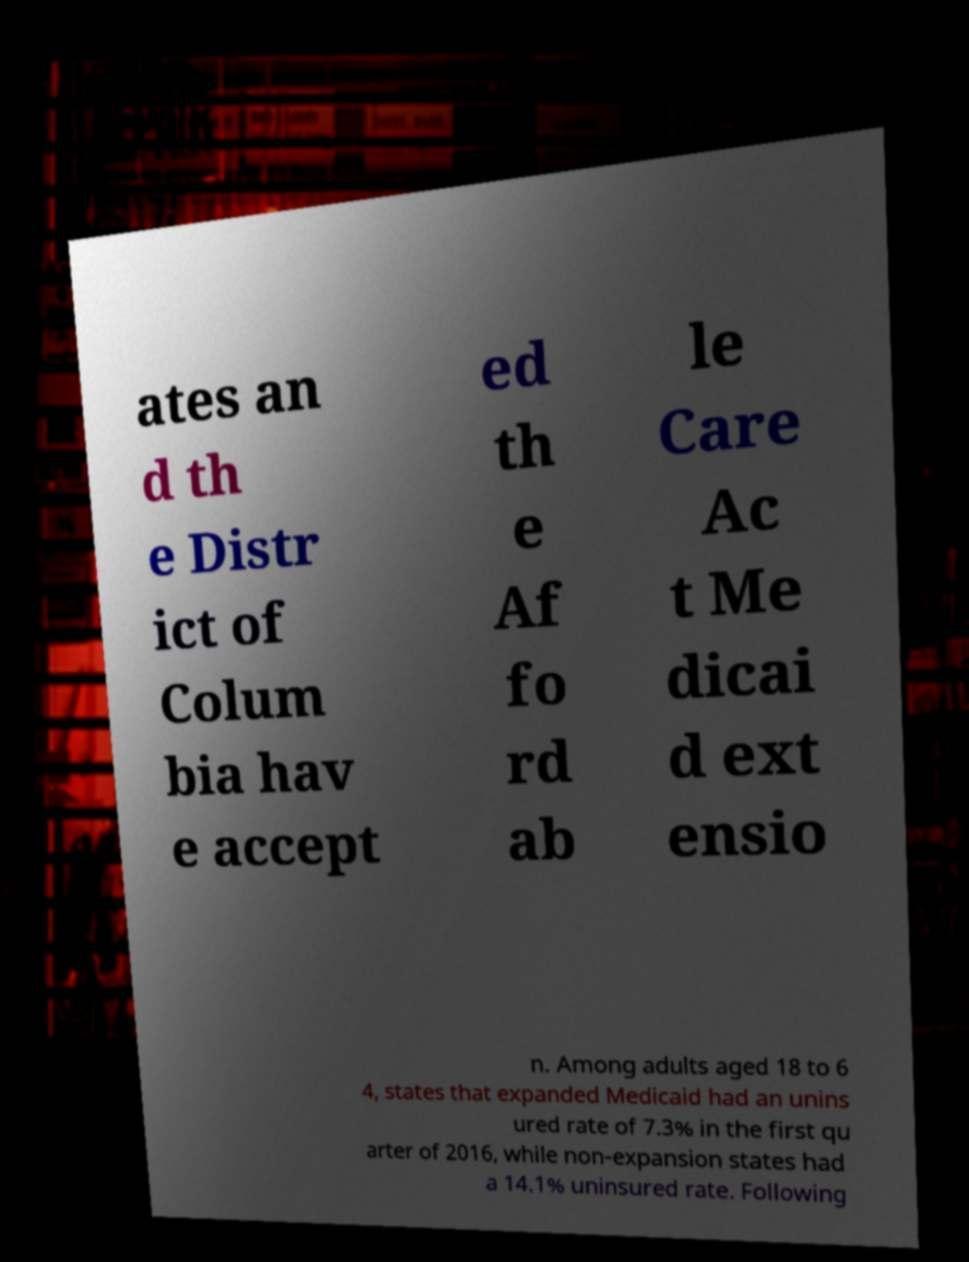For documentation purposes, I need the text within this image transcribed. Could you provide that? ates an d th e Distr ict of Colum bia hav e accept ed th e Af fo rd ab le Care Ac t Me dicai d ext ensio n. Among adults aged 18 to 6 4, states that expanded Medicaid had an unins ured rate of 7.3% in the first qu arter of 2016, while non-expansion states had a 14.1% uninsured rate. Following 